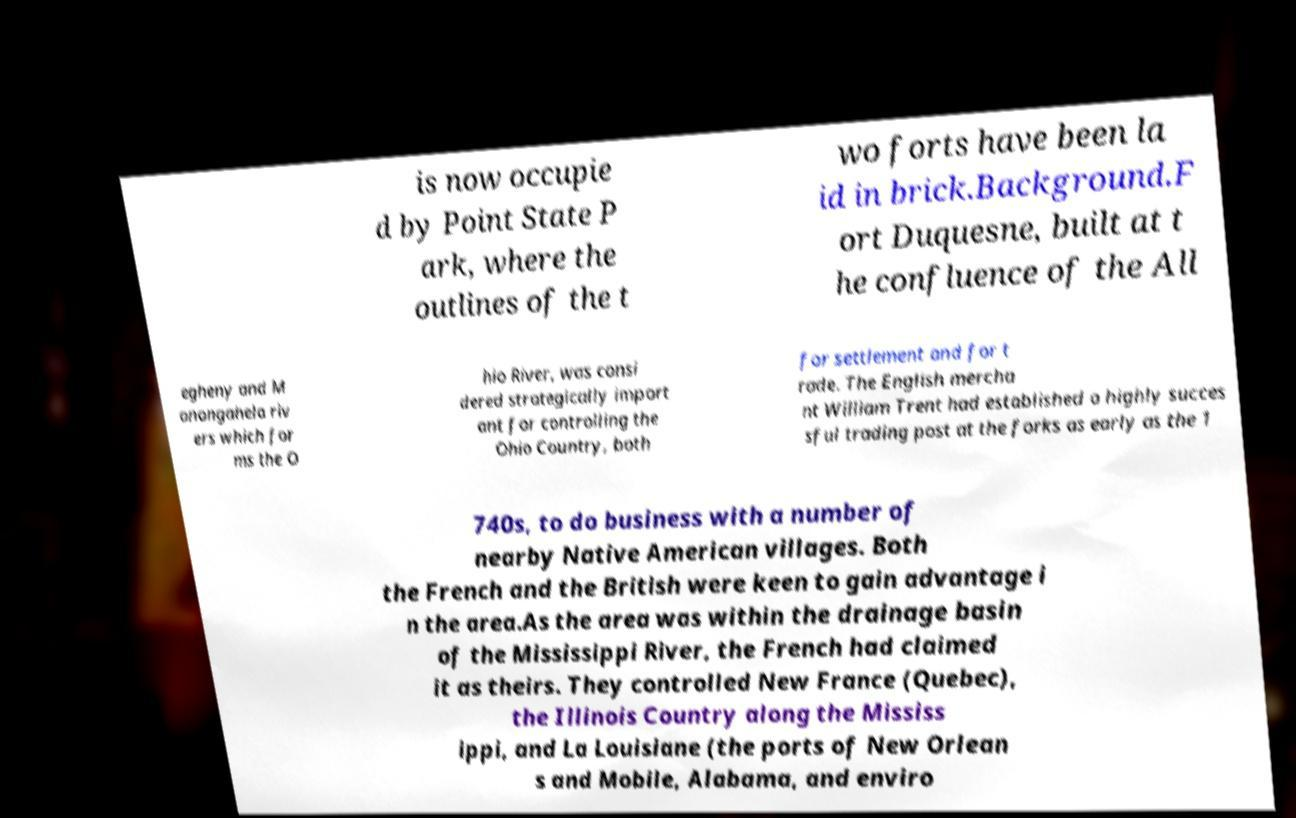Please read and relay the text visible in this image. What does it say? is now occupie d by Point State P ark, where the outlines of the t wo forts have been la id in brick.Background.F ort Duquesne, built at t he confluence of the All egheny and M onongahela riv ers which for ms the O hio River, was consi dered strategically import ant for controlling the Ohio Country, both for settlement and for t rade. The English mercha nt William Trent had established a highly succes sful trading post at the forks as early as the 1 740s, to do business with a number of nearby Native American villages. Both the French and the British were keen to gain advantage i n the area.As the area was within the drainage basin of the Mississippi River, the French had claimed it as theirs. They controlled New France (Quebec), the Illinois Country along the Mississ ippi, and La Louisiane (the ports of New Orlean s and Mobile, Alabama, and enviro 